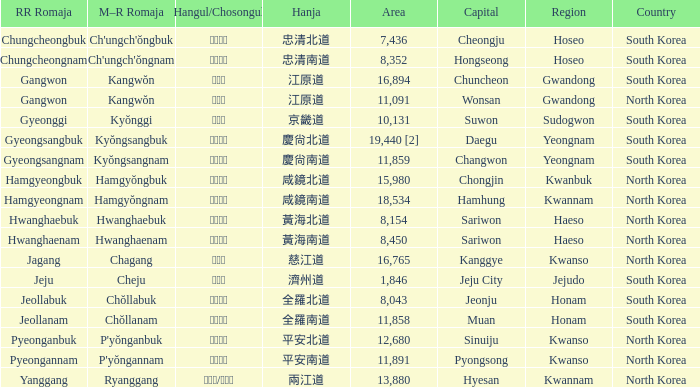What is the area for the province having Hangul of 경기도? 10131.0. 